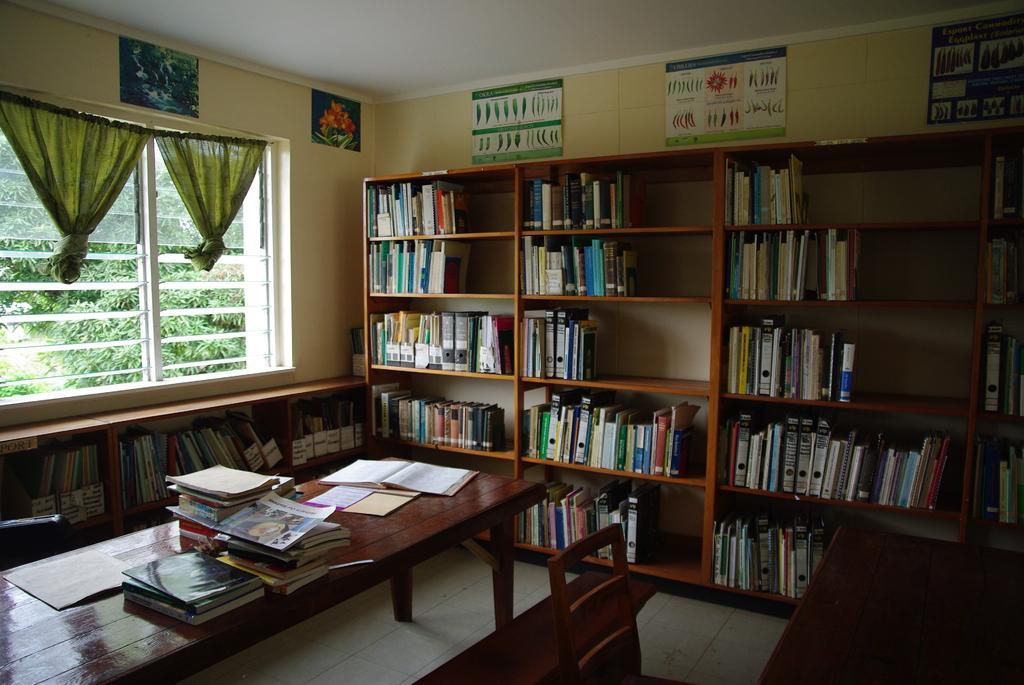Describe this image in one or two sentences. Here we can see a window, through it we can see trees. These are curtains in green colour. We can see few posts over a wall. We can see arack where books are arranged in a sequence manner. here we can see chairs and tables. On the table we can see books. Here we can see files arranged in a rack. This is a floor. 